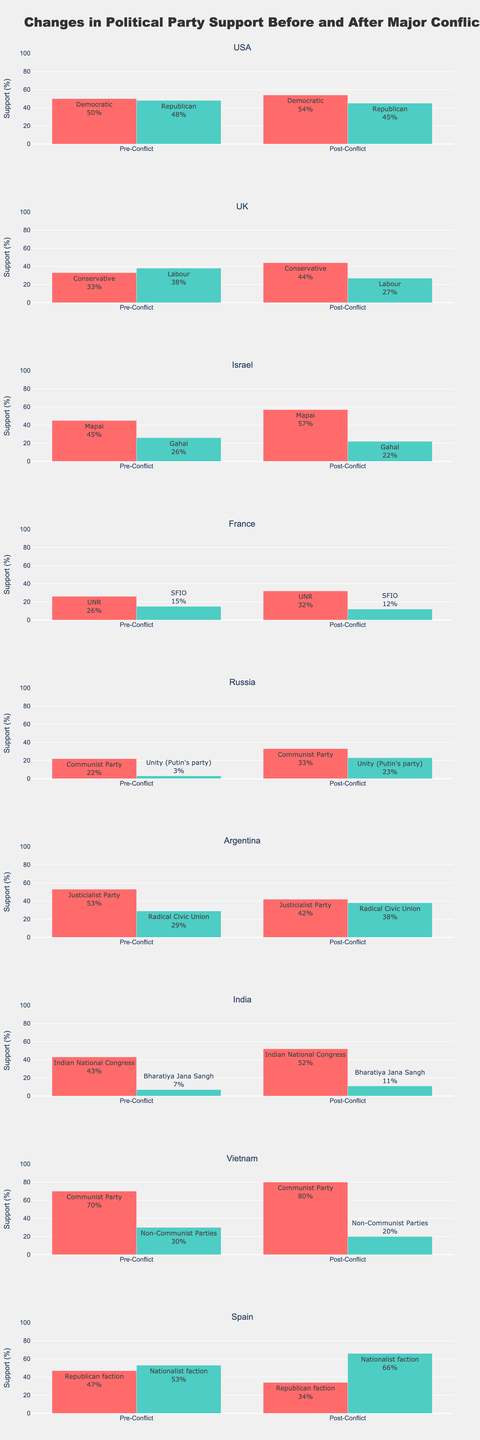Which country saw the greatest increase in support for a political party after a conflict? To determine the greatest increase in support, find the difference between Pre-Conflict and Post-Conflict support for each party in all countries. The largest increase is observed in the Nationalist faction in Spain, which increased from 53% to 66%, a 13% increase.
Answer: Spain Which political party's support decreased the most after the conflict? Identify the party with the largest drop in percentage support by comparing Pre-Conflict and Post-Conflict values. The Republican faction in Spain saw a 13% decrease from 47% to 34%.
Answer: Republican faction in Spain What is the average change in support for Indian political parties after the Indo-Pakistani War of 1971? Calculate the change in support for both Indian parties and then find the average. Indian National Congress: 52% - 43% = 9%. Bharatiya Jana Sangh: 11% - 7% = 4%. Average change: (4 + 9) / 2 = 6.5%.
Answer: 6.5% Which country's parties have the closest post-conflict support percentages? Compare the Post-Conflict Support percentages for each pair of parties in all countries. USA's Democratic and Republican parties have post-conflict supports of 54% and 45%, respectively, the closest compared to other countries.
Answer: USA What is the total percentage support increase for all parties in the UK after the Falklands War? Sum the differences between Pre-Conflict and Post-Conflict support for all parties in the UK. Conservative: 44% - 33% = 11%. Labour: 27% - 38% = -11%. Total increase: 11 + (-11) = 0%.
Answer: 0% Which party in Argentina experienced a shift from being the most popular pre-conflict to the less popular post-conflict? Compare Pre-Conflict and Post-Conflict percentages for Argentina's parties. The Justicialist Party went from 53% to 42%, and the Radical Civic Union from 29% to 38%, making the Justicialist Party less popular post-conflict.
Answer: Justicialist Party Did any party in any country consistently hold more than 50% support pre- and post-conflict? Check if any party in both Pre-Conflict and Post-Conflict columns has values above 50%. In Vietnam, the Communist Party had 70% pre-conflict and 80% post-conflict, both over 50%.
Answer: Communist Party in Vietnam How does the post-conflict support for the French SFIO party compare to the pre-conflict support of the Israeli Gahal party? Compare the Post-Conflict support for the French SFIO party (12%) to the Pre-Conflict support for the Israeli Gahal party (26%).
Answer: French SFIO has lower support post-conflict What is the difference in post-conflict support between the USA's Democratic and Republican parties? Subtract the post-conflict support of the Republican party from that of the Democratic party. Democratic: 54%, Republican: 45%. Difference: 54% - 45% = 9%.
Answer: 9% 